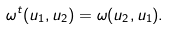<formula> <loc_0><loc_0><loc_500><loc_500>\omega ^ { t } ( u _ { 1 } , u _ { 2 } ) = \omega ( u _ { 2 } , u _ { 1 } ) .</formula> 